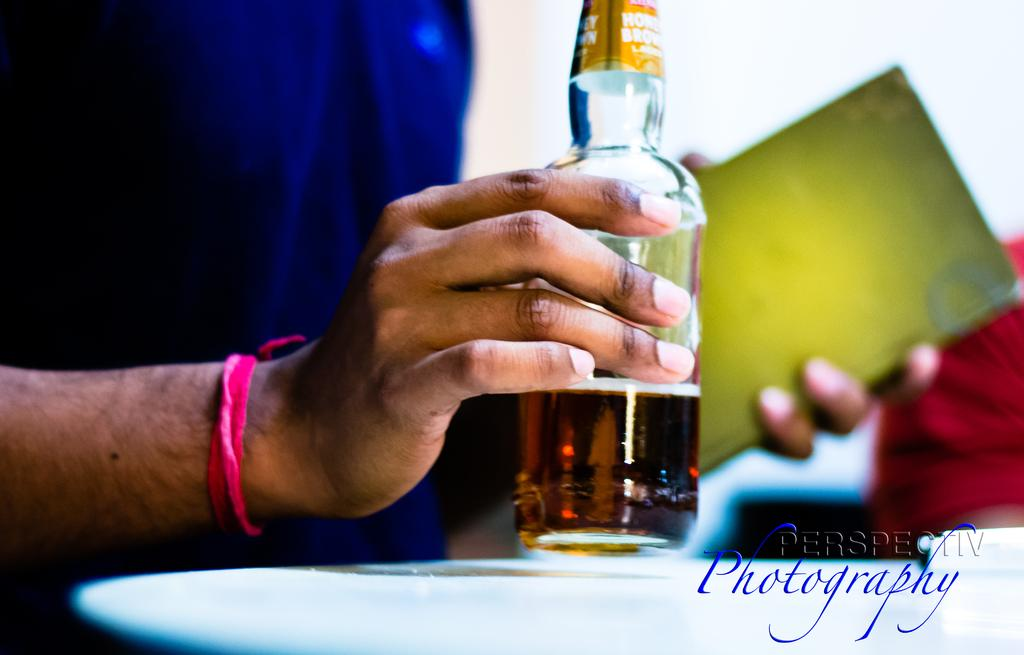What is the main object being held in the image? There is a wine bottle in the image, and it is held in a hand. What else can be seen on the table in the image? There is a plate on the table in the image. Can you see the coach sitting next to the window in the image? There is no coach or window present in the image; it only features a wine bottle being held in a hand and a plate on the table. 